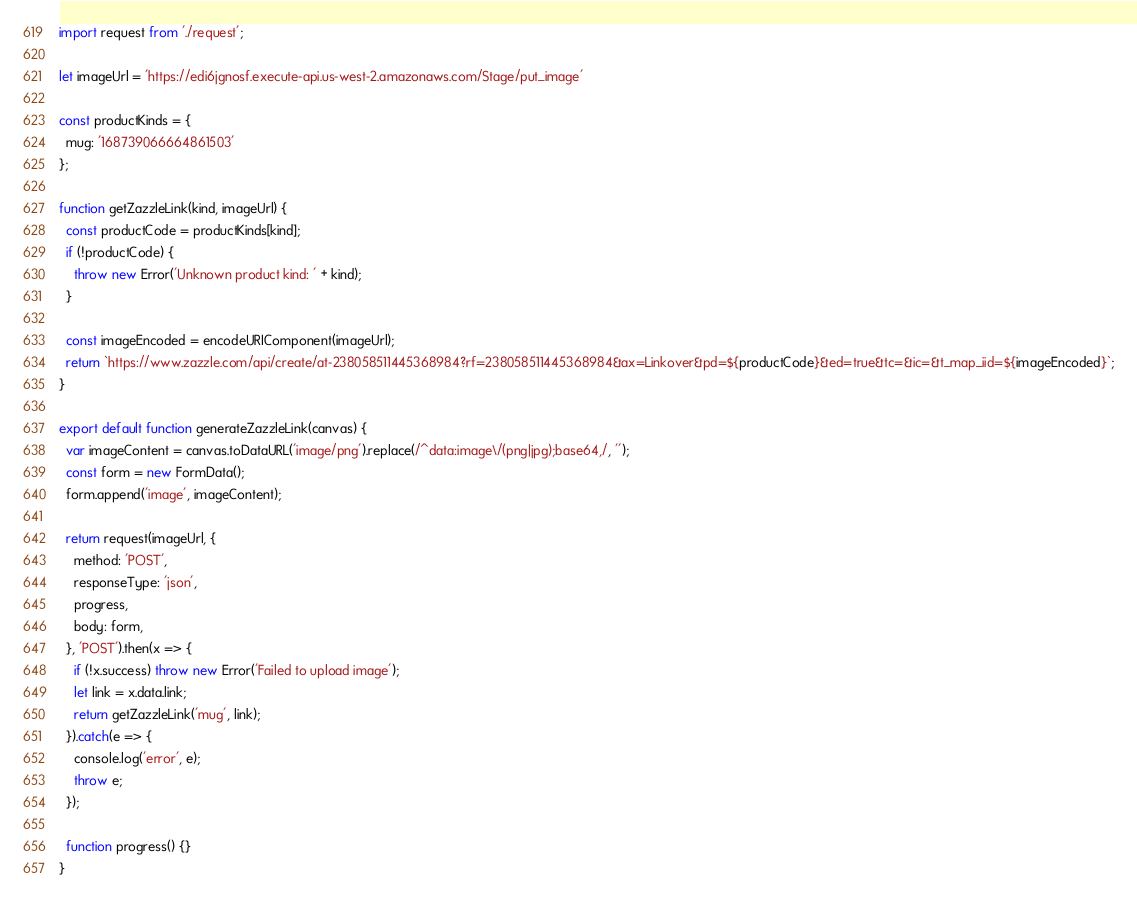Convert code to text. <code><loc_0><loc_0><loc_500><loc_500><_JavaScript_>import request from './request';

let imageUrl = 'https://edi6jgnosf.execute-api.us-west-2.amazonaws.com/Stage/put_image'

const productKinds = {
  mug: '168739066664861503'
};

function getZazzleLink(kind, imageUrl) {
  const productCode = productKinds[kind];
  if (!productCode) {
    throw new Error('Unknown product kind: ' + kind);
  }

  const imageEncoded = encodeURIComponent(imageUrl);
  return `https://www.zazzle.com/api/create/at-238058511445368984?rf=238058511445368984&ax=Linkover&pd=${productCode}&ed=true&tc=&ic=&t_map_iid=${imageEncoded}`;
}

export default function generateZazzleLink(canvas) {
  var imageContent = canvas.toDataURL('image/png').replace(/^data:image\/(png|jpg);base64,/, '');
  const form = new FormData();
  form.append('image', imageContent);

  return request(imageUrl, {
    method: 'POST',
    responseType: 'json',
    progress,
    body: form,
  }, 'POST').then(x => {
    if (!x.success) throw new Error('Failed to upload image');
    let link = x.data.link; 
    return getZazzleLink('mug', link);
  }).catch(e => {
    console.log('error', e);
    throw e;
  });

  function progress() {}
}</code> 